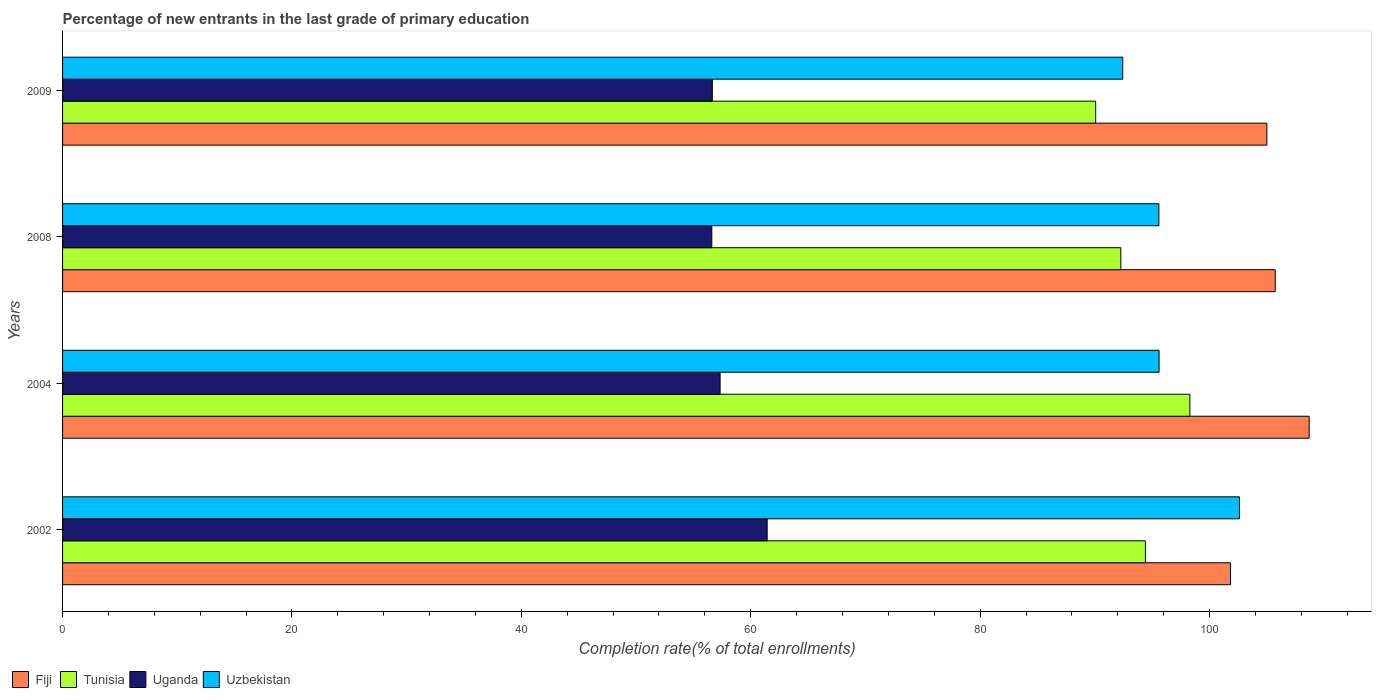How many different coloured bars are there?
Keep it short and to the point. 4. How many groups of bars are there?
Make the answer very short. 4. Are the number of bars per tick equal to the number of legend labels?
Provide a short and direct response. Yes. How many bars are there on the 3rd tick from the bottom?
Provide a short and direct response. 4. What is the label of the 2nd group of bars from the top?
Your answer should be compact. 2008. In how many cases, is the number of bars for a given year not equal to the number of legend labels?
Provide a short and direct response. 0. What is the percentage of new entrants in Uzbekistan in 2002?
Provide a short and direct response. 102.61. Across all years, what is the maximum percentage of new entrants in Uganda?
Offer a terse response. 61.43. Across all years, what is the minimum percentage of new entrants in Fiji?
Offer a terse response. 101.83. In which year was the percentage of new entrants in Uzbekistan minimum?
Your answer should be compact. 2009. What is the total percentage of new entrants in Fiji in the graph?
Provide a succinct answer. 421.24. What is the difference between the percentage of new entrants in Tunisia in 2002 and that in 2008?
Your response must be concise. 2.14. What is the difference between the percentage of new entrants in Uzbekistan in 2004 and the percentage of new entrants in Tunisia in 2009?
Ensure brevity in your answer.  5.53. What is the average percentage of new entrants in Tunisia per year?
Your answer should be compact. 93.76. In the year 2009, what is the difference between the percentage of new entrants in Uzbekistan and percentage of new entrants in Tunisia?
Your answer should be very brief. 2.36. In how many years, is the percentage of new entrants in Fiji greater than 88 %?
Provide a short and direct response. 4. What is the ratio of the percentage of new entrants in Uganda in 2002 to that in 2004?
Offer a very short reply. 1.07. What is the difference between the highest and the second highest percentage of new entrants in Fiji?
Give a very brief answer. 2.96. What is the difference between the highest and the lowest percentage of new entrants in Uganda?
Your response must be concise. 4.83. In how many years, is the percentage of new entrants in Uganda greater than the average percentage of new entrants in Uganda taken over all years?
Offer a terse response. 1. Is it the case that in every year, the sum of the percentage of new entrants in Uganda and percentage of new entrants in Uzbekistan is greater than the sum of percentage of new entrants in Tunisia and percentage of new entrants in Fiji?
Keep it short and to the point. No. What does the 1st bar from the top in 2002 represents?
Your answer should be compact. Uzbekistan. What does the 3rd bar from the bottom in 2004 represents?
Keep it short and to the point. Uganda. Are all the bars in the graph horizontal?
Your response must be concise. Yes. How many years are there in the graph?
Provide a succinct answer. 4. What is the difference between two consecutive major ticks on the X-axis?
Offer a very short reply. 20. Does the graph contain any zero values?
Your answer should be compact. No. Does the graph contain grids?
Keep it short and to the point. No. Where does the legend appear in the graph?
Your answer should be very brief. Bottom left. How many legend labels are there?
Provide a short and direct response. 4. How are the legend labels stacked?
Your response must be concise. Horizontal. What is the title of the graph?
Your response must be concise. Percentage of new entrants in the last grade of primary education. What is the label or title of the X-axis?
Provide a short and direct response. Completion rate(% of total enrollments). What is the Completion rate(% of total enrollments) of Fiji in 2002?
Provide a succinct answer. 101.83. What is the Completion rate(% of total enrollments) of Tunisia in 2002?
Offer a terse response. 94.41. What is the Completion rate(% of total enrollments) in Uganda in 2002?
Give a very brief answer. 61.43. What is the Completion rate(% of total enrollments) in Uzbekistan in 2002?
Give a very brief answer. 102.61. What is the Completion rate(% of total enrollments) in Fiji in 2004?
Provide a short and direct response. 108.69. What is the Completion rate(% of total enrollments) of Tunisia in 2004?
Keep it short and to the point. 98.28. What is the Completion rate(% of total enrollments) in Uganda in 2004?
Your answer should be compact. 57.33. What is the Completion rate(% of total enrollments) of Uzbekistan in 2004?
Keep it short and to the point. 95.6. What is the Completion rate(% of total enrollments) in Fiji in 2008?
Keep it short and to the point. 105.73. What is the Completion rate(% of total enrollments) in Tunisia in 2008?
Your answer should be compact. 92.27. What is the Completion rate(% of total enrollments) of Uganda in 2008?
Offer a terse response. 56.61. What is the Completion rate(% of total enrollments) in Uzbekistan in 2008?
Keep it short and to the point. 95.58. What is the Completion rate(% of total enrollments) of Fiji in 2009?
Provide a short and direct response. 105. What is the Completion rate(% of total enrollments) of Tunisia in 2009?
Offer a very short reply. 90.07. What is the Completion rate(% of total enrollments) of Uganda in 2009?
Your answer should be very brief. 56.65. What is the Completion rate(% of total enrollments) of Uzbekistan in 2009?
Provide a succinct answer. 92.43. Across all years, what is the maximum Completion rate(% of total enrollments) of Fiji?
Offer a very short reply. 108.69. Across all years, what is the maximum Completion rate(% of total enrollments) in Tunisia?
Provide a succinct answer. 98.28. Across all years, what is the maximum Completion rate(% of total enrollments) of Uganda?
Your answer should be compact. 61.43. Across all years, what is the maximum Completion rate(% of total enrollments) in Uzbekistan?
Ensure brevity in your answer.  102.61. Across all years, what is the minimum Completion rate(% of total enrollments) of Fiji?
Ensure brevity in your answer.  101.83. Across all years, what is the minimum Completion rate(% of total enrollments) of Tunisia?
Your answer should be very brief. 90.07. Across all years, what is the minimum Completion rate(% of total enrollments) in Uganda?
Make the answer very short. 56.61. Across all years, what is the minimum Completion rate(% of total enrollments) in Uzbekistan?
Ensure brevity in your answer.  92.43. What is the total Completion rate(% of total enrollments) in Fiji in the graph?
Your answer should be compact. 421.24. What is the total Completion rate(% of total enrollments) of Tunisia in the graph?
Provide a short and direct response. 375.04. What is the total Completion rate(% of total enrollments) in Uganda in the graph?
Provide a short and direct response. 232.02. What is the total Completion rate(% of total enrollments) in Uzbekistan in the graph?
Your answer should be very brief. 386.22. What is the difference between the Completion rate(% of total enrollments) in Fiji in 2002 and that in 2004?
Make the answer very short. -6.86. What is the difference between the Completion rate(% of total enrollments) of Tunisia in 2002 and that in 2004?
Ensure brevity in your answer.  -3.87. What is the difference between the Completion rate(% of total enrollments) of Uganda in 2002 and that in 2004?
Offer a terse response. 4.1. What is the difference between the Completion rate(% of total enrollments) in Uzbekistan in 2002 and that in 2004?
Give a very brief answer. 7.01. What is the difference between the Completion rate(% of total enrollments) in Tunisia in 2002 and that in 2008?
Provide a short and direct response. 2.14. What is the difference between the Completion rate(% of total enrollments) of Uganda in 2002 and that in 2008?
Provide a succinct answer. 4.83. What is the difference between the Completion rate(% of total enrollments) of Uzbekistan in 2002 and that in 2008?
Your response must be concise. 7.02. What is the difference between the Completion rate(% of total enrollments) of Fiji in 2002 and that in 2009?
Offer a terse response. -3.17. What is the difference between the Completion rate(% of total enrollments) of Tunisia in 2002 and that in 2009?
Offer a very short reply. 4.34. What is the difference between the Completion rate(% of total enrollments) of Uganda in 2002 and that in 2009?
Make the answer very short. 4.78. What is the difference between the Completion rate(% of total enrollments) in Uzbekistan in 2002 and that in 2009?
Provide a succinct answer. 10.17. What is the difference between the Completion rate(% of total enrollments) of Fiji in 2004 and that in 2008?
Your answer should be very brief. 2.96. What is the difference between the Completion rate(% of total enrollments) in Tunisia in 2004 and that in 2008?
Provide a short and direct response. 6.02. What is the difference between the Completion rate(% of total enrollments) of Uganda in 2004 and that in 2008?
Your answer should be compact. 0.72. What is the difference between the Completion rate(% of total enrollments) of Uzbekistan in 2004 and that in 2008?
Provide a short and direct response. 0.02. What is the difference between the Completion rate(% of total enrollments) in Fiji in 2004 and that in 2009?
Your answer should be very brief. 3.69. What is the difference between the Completion rate(% of total enrollments) in Tunisia in 2004 and that in 2009?
Your answer should be compact. 8.21. What is the difference between the Completion rate(% of total enrollments) of Uganda in 2004 and that in 2009?
Offer a terse response. 0.68. What is the difference between the Completion rate(% of total enrollments) in Uzbekistan in 2004 and that in 2009?
Your response must be concise. 3.17. What is the difference between the Completion rate(% of total enrollments) of Fiji in 2008 and that in 2009?
Offer a very short reply. 0.73. What is the difference between the Completion rate(% of total enrollments) in Tunisia in 2008 and that in 2009?
Keep it short and to the point. 2.2. What is the difference between the Completion rate(% of total enrollments) in Uganda in 2008 and that in 2009?
Your answer should be compact. -0.04. What is the difference between the Completion rate(% of total enrollments) of Uzbekistan in 2008 and that in 2009?
Provide a succinct answer. 3.15. What is the difference between the Completion rate(% of total enrollments) of Fiji in 2002 and the Completion rate(% of total enrollments) of Tunisia in 2004?
Your response must be concise. 3.54. What is the difference between the Completion rate(% of total enrollments) of Fiji in 2002 and the Completion rate(% of total enrollments) of Uganda in 2004?
Offer a very short reply. 44.5. What is the difference between the Completion rate(% of total enrollments) in Fiji in 2002 and the Completion rate(% of total enrollments) in Uzbekistan in 2004?
Offer a very short reply. 6.22. What is the difference between the Completion rate(% of total enrollments) in Tunisia in 2002 and the Completion rate(% of total enrollments) in Uganda in 2004?
Make the answer very short. 37.08. What is the difference between the Completion rate(% of total enrollments) in Tunisia in 2002 and the Completion rate(% of total enrollments) in Uzbekistan in 2004?
Your response must be concise. -1.19. What is the difference between the Completion rate(% of total enrollments) in Uganda in 2002 and the Completion rate(% of total enrollments) in Uzbekistan in 2004?
Your response must be concise. -34.17. What is the difference between the Completion rate(% of total enrollments) in Fiji in 2002 and the Completion rate(% of total enrollments) in Tunisia in 2008?
Offer a terse response. 9.56. What is the difference between the Completion rate(% of total enrollments) in Fiji in 2002 and the Completion rate(% of total enrollments) in Uganda in 2008?
Offer a very short reply. 45.22. What is the difference between the Completion rate(% of total enrollments) of Fiji in 2002 and the Completion rate(% of total enrollments) of Uzbekistan in 2008?
Offer a very short reply. 6.24. What is the difference between the Completion rate(% of total enrollments) of Tunisia in 2002 and the Completion rate(% of total enrollments) of Uganda in 2008?
Give a very brief answer. 37.81. What is the difference between the Completion rate(% of total enrollments) of Tunisia in 2002 and the Completion rate(% of total enrollments) of Uzbekistan in 2008?
Offer a very short reply. -1.17. What is the difference between the Completion rate(% of total enrollments) of Uganda in 2002 and the Completion rate(% of total enrollments) of Uzbekistan in 2008?
Give a very brief answer. -34.15. What is the difference between the Completion rate(% of total enrollments) of Fiji in 2002 and the Completion rate(% of total enrollments) of Tunisia in 2009?
Keep it short and to the point. 11.75. What is the difference between the Completion rate(% of total enrollments) of Fiji in 2002 and the Completion rate(% of total enrollments) of Uganda in 2009?
Keep it short and to the point. 45.17. What is the difference between the Completion rate(% of total enrollments) of Fiji in 2002 and the Completion rate(% of total enrollments) of Uzbekistan in 2009?
Offer a terse response. 9.39. What is the difference between the Completion rate(% of total enrollments) of Tunisia in 2002 and the Completion rate(% of total enrollments) of Uganda in 2009?
Offer a very short reply. 37.76. What is the difference between the Completion rate(% of total enrollments) of Tunisia in 2002 and the Completion rate(% of total enrollments) of Uzbekistan in 2009?
Give a very brief answer. 1.98. What is the difference between the Completion rate(% of total enrollments) of Uganda in 2002 and the Completion rate(% of total enrollments) of Uzbekistan in 2009?
Give a very brief answer. -31. What is the difference between the Completion rate(% of total enrollments) of Fiji in 2004 and the Completion rate(% of total enrollments) of Tunisia in 2008?
Ensure brevity in your answer.  16.42. What is the difference between the Completion rate(% of total enrollments) of Fiji in 2004 and the Completion rate(% of total enrollments) of Uganda in 2008?
Offer a very short reply. 52.08. What is the difference between the Completion rate(% of total enrollments) of Fiji in 2004 and the Completion rate(% of total enrollments) of Uzbekistan in 2008?
Ensure brevity in your answer.  13.1. What is the difference between the Completion rate(% of total enrollments) in Tunisia in 2004 and the Completion rate(% of total enrollments) in Uganda in 2008?
Keep it short and to the point. 41.68. What is the difference between the Completion rate(% of total enrollments) of Tunisia in 2004 and the Completion rate(% of total enrollments) of Uzbekistan in 2008?
Your response must be concise. 2.7. What is the difference between the Completion rate(% of total enrollments) in Uganda in 2004 and the Completion rate(% of total enrollments) in Uzbekistan in 2008?
Your answer should be very brief. -38.26. What is the difference between the Completion rate(% of total enrollments) of Fiji in 2004 and the Completion rate(% of total enrollments) of Tunisia in 2009?
Keep it short and to the point. 18.61. What is the difference between the Completion rate(% of total enrollments) in Fiji in 2004 and the Completion rate(% of total enrollments) in Uganda in 2009?
Ensure brevity in your answer.  52.04. What is the difference between the Completion rate(% of total enrollments) of Fiji in 2004 and the Completion rate(% of total enrollments) of Uzbekistan in 2009?
Give a very brief answer. 16.26. What is the difference between the Completion rate(% of total enrollments) in Tunisia in 2004 and the Completion rate(% of total enrollments) in Uganda in 2009?
Provide a succinct answer. 41.63. What is the difference between the Completion rate(% of total enrollments) in Tunisia in 2004 and the Completion rate(% of total enrollments) in Uzbekistan in 2009?
Your response must be concise. 5.85. What is the difference between the Completion rate(% of total enrollments) of Uganda in 2004 and the Completion rate(% of total enrollments) of Uzbekistan in 2009?
Your response must be concise. -35.1. What is the difference between the Completion rate(% of total enrollments) of Fiji in 2008 and the Completion rate(% of total enrollments) of Tunisia in 2009?
Offer a terse response. 15.65. What is the difference between the Completion rate(% of total enrollments) in Fiji in 2008 and the Completion rate(% of total enrollments) in Uganda in 2009?
Offer a very short reply. 49.07. What is the difference between the Completion rate(% of total enrollments) of Fiji in 2008 and the Completion rate(% of total enrollments) of Uzbekistan in 2009?
Provide a short and direct response. 13.29. What is the difference between the Completion rate(% of total enrollments) of Tunisia in 2008 and the Completion rate(% of total enrollments) of Uganda in 2009?
Make the answer very short. 35.62. What is the difference between the Completion rate(% of total enrollments) in Tunisia in 2008 and the Completion rate(% of total enrollments) in Uzbekistan in 2009?
Your response must be concise. -0.16. What is the difference between the Completion rate(% of total enrollments) of Uganda in 2008 and the Completion rate(% of total enrollments) of Uzbekistan in 2009?
Ensure brevity in your answer.  -35.83. What is the average Completion rate(% of total enrollments) in Fiji per year?
Ensure brevity in your answer.  105.31. What is the average Completion rate(% of total enrollments) in Tunisia per year?
Your answer should be compact. 93.76. What is the average Completion rate(% of total enrollments) of Uganda per year?
Keep it short and to the point. 58. What is the average Completion rate(% of total enrollments) of Uzbekistan per year?
Your answer should be compact. 96.56. In the year 2002, what is the difference between the Completion rate(% of total enrollments) of Fiji and Completion rate(% of total enrollments) of Tunisia?
Offer a very short reply. 7.41. In the year 2002, what is the difference between the Completion rate(% of total enrollments) in Fiji and Completion rate(% of total enrollments) in Uganda?
Offer a very short reply. 40.39. In the year 2002, what is the difference between the Completion rate(% of total enrollments) of Fiji and Completion rate(% of total enrollments) of Uzbekistan?
Your response must be concise. -0.78. In the year 2002, what is the difference between the Completion rate(% of total enrollments) in Tunisia and Completion rate(% of total enrollments) in Uganda?
Ensure brevity in your answer.  32.98. In the year 2002, what is the difference between the Completion rate(% of total enrollments) of Tunisia and Completion rate(% of total enrollments) of Uzbekistan?
Your response must be concise. -8.19. In the year 2002, what is the difference between the Completion rate(% of total enrollments) in Uganda and Completion rate(% of total enrollments) in Uzbekistan?
Provide a short and direct response. -41.17. In the year 2004, what is the difference between the Completion rate(% of total enrollments) of Fiji and Completion rate(% of total enrollments) of Tunisia?
Offer a very short reply. 10.4. In the year 2004, what is the difference between the Completion rate(% of total enrollments) in Fiji and Completion rate(% of total enrollments) in Uganda?
Keep it short and to the point. 51.36. In the year 2004, what is the difference between the Completion rate(% of total enrollments) of Fiji and Completion rate(% of total enrollments) of Uzbekistan?
Provide a succinct answer. 13.09. In the year 2004, what is the difference between the Completion rate(% of total enrollments) in Tunisia and Completion rate(% of total enrollments) in Uganda?
Your answer should be very brief. 40.96. In the year 2004, what is the difference between the Completion rate(% of total enrollments) in Tunisia and Completion rate(% of total enrollments) in Uzbekistan?
Give a very brief answer. 2.68. In the year 2004, what is the difference between the Completion rate(% of total enrollments) in Uganda and Completion rate(% of total enrollments) in Uzbekistan?
Offer a terse response. -38.27. In the year 2008, what is the difference between the Completion rate(% of total enrollments) in Fiji and Completion rate(% of total enrollments) in Tunisia?
Give a very brief answer. 13.46. In the year 2008, what is the difference between the Completion rate(% of total enrollments) of Fiji and Completion rate(% of total enrollments) of Uganda?
Ensure brevity in your answer.  49.12. In the year 2008, what is the difference between the Completion rate(% of total enrollments) of Fiji and Completion rate(% of total enrollments) of Uzbekistan?
Provide a short and direct response. 10.14. In the year 2008, what is the difference between the Completion rate(% of total enrollments) of Tunisia and Completion rate(% of total enrollments) of Uganda?
Your answer should be very brief. 35.66. In the year 2008, what is the difference between the Completion rate(% of total enrollments) in Tunisia and Completion rate(% of total enrollments) in Uzbekistan?
Your answer should be compact. -3.32. In the year 2008, what is the difference between the Completion rate(% of total enrollments) in Uganda and Completion rate(% of total enrollments) in Uzbekistan?
Keep it short and to the point. -38.98. In the year 2009, what is the difference between the Completion rate(% of total enrollments) in Fiji and Completion rate(% of total enrollments) in Tunisia?
Your answer should be compact. 14.93. In the year 2009, what is the difference between the Completion rate(% of total enrollments) of Fiji and Completion rate(% of total enrollments) of Uganda?
Provide a short and direct response. 48.35. In the year 2009, what is the difference between the Completion rate(% of total enrollments) of Fiji and Completion rate(% of total enrollments) of Uzbekistan?
Make the answer very short. 12.57. In the year 2009, what is the difference between the Completion rate(% of total enrollments) of Tunisia and Completion rate(% of total enrollments) of Uganda?
Make the answer very short. 33.42. In the year 2009, what is the difference between the Completion rate(% of total enrollments) of Tunisia and Completion rate(% of total enrollments) of Uzbekistan?
Provide a short and direct response. -2.36. In the year 2009, what is the difference between the Completion rate(% of total enrollments) of Uganda and Completion rate(% of total enrollments) of Uzbekistan?
Offer a terse response. -35.78. What is the ratio of the Completion rate(% of total enrollments) in Fiji in 2002 to that in 2004?
Offer a terse response. 0.94. What is the ratio of the Completion rate(% of total enrollments) in Tunisia in 2002 to that in 2004?
Keep it short and to the point. 0.96. What is the ratio of the Completion rate(% of total enrollments) in Uganda in 2002 to that in 2004?
Offer a terse response. 1.07. What is the ratio of the Completion rate(% of total enrollments) of Uzbekistan in 2002 to that in 2004?
Your response must be concise. 1.07. What is the ratio of the Completion rate(% of total enrollments) in Fiji in 2002 to that in 2008?
Give a very brief answer. 0.96. What is the ratio of the Completion rate(% of total enrollments) in Tunisia in 2002 to that in 2008?
Your answer should be very brief. 1.02. What is the ratio of the Completion rate(% of total enrollments) of Uganda in 2002 to that in 2008?
Keep it short and to the point. 1.09. What is the ratio of the Completion rate(% of total enrollments) in Uzbekistan in 2002 to that in 2008?
Your answer should be very brief. 1.07. What is the ratio of the Completion rate(% of total enrollments) of Fiji in 2002 to that in 2009?
Offer a terse response. 0.97. What is the ratio of the Completion rate(% of total enrollments) of Tunisia in 2002 to that in 2009?
Offer a terse response. 1.05. What is the ratio of the Completion rate(% of total enrollments) of Uganda in 2002 to that in 2009?
Give a very brief answer. 1.08. What is the ratio of the Completion rate(% of total enrollments) of Uzbekistan in 2002 to that in 2009?
Make the answer very short. 1.11. What is the ratio of the Completion rate(% of total enrollments) in Fiji in 2004 to that in 2008?
Your answer should be very brief. 1.03. What is the ratio of the Completion rate(% of total enrollments) of Tunisia in 2004 to that in 2008?
Ensure brevity in your answer.  1.07. What is the ratio of the Completion rate(% of total enrollments) of Uganda in 2004 to that in 2008?
Offer a terse response. 1.01. What is the ratio of the Completion rate(% of total enrollments) in Uzbekistan in 2004 to that in 2008?
Give a very brief answer. 1. What is the ratio of the Completion rate(% of total enrollments) in Fiji in 2004 to that in 2009?
Offer a very short reply. 1.04. What is the ratio of the Completion rate(% of total enrollments) in Tunisia in 2004 to that in 2009?
Keep it short and to the point. 1.09. What is the ratio of the Completion rate(% of total enrollments) of Uganda in 2004 to that in 2009?
Provide a succinct answer. 1.01. What is the ratio of the Completion rate(% of total enrollments) of Uzbekistan in 2004 to that in 2009?
Your response must be concise. 1.03. What is the ratio of the Completion rate(% of total enrollments) of Fiji in 2008 to that in 2009?
Your response must be concise. 1.01. What is the ratio of the Completion rate(% of total enrollments) of Tunisia in 2008 to that in 2009?
Make the answer very short. 1.02. What is the ratio of the Completion rate(% of total enrollments) of Uganda in 2008 to that in 2009?
Ensure brevity in your answer.  1. What is the ratio of the Completion rate(% of total enrollments) in Uzbekistan in 2008 to that in 2009?
Keep it short and to the point. 1.03. What is the difference between the highest and the second highest Completion rate(% of total enrollments) in Fiji?
Keep it short and to the point. 2.96. What is the difference between the highest and the second highest Completion rate(% of total enrollments) in Tunisia?
Provide a short and direct response. 3.87. What is the difference between the highest and the second highest Completion rate(% of total enrollments) in Uganda?
Provide a short and direct response. 4.1. What is the difference between the highest and the second highest Completion rate(% of total enrollments) of Uzbekistan?
Ensure brevity in your answer.  7.01. What is the difference between the highest and the lowest Completion rate(% of total enrollments) in Fiji?
Provide a short and direct response. 6.86. What is the difference between the highest and the lowest Completion rate(% of total enrollments) in Tunisia?
Offer a terse response. 8.21. What is the difference between the highest and the lowest Completion rate(% of total enrollments) of Uganda?
Your response must be concise. 4.83. What is the difference between the highest and the lowest Completion rate(% of total enrollments) in Uzbekistan?
Provide a short and direct response. 10.17. 